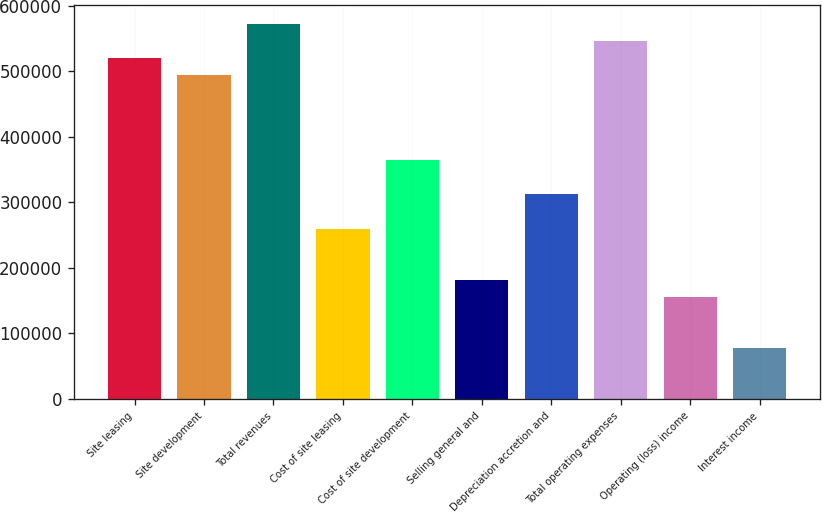<chart> <loc_0><loc_0><loc_500><loc_500><bar_chart><fcel>Site leasing<fcel>Site development<fcel>Total revenues<fcel>Cost of site leasing<fcel>Cost of site development<fcel>Selling general and<fcel>Depreciation accretion and<fcel>Total operating expenses<fcel>Operating (loss) income<fcel>Interest income<nl><fcel>519981<fcel>493982<fcel>571979<fcel>259991<fcel>363987<fcel>181994<fcel>311989<fcel>545980<fcel>155995<fcel>77998.2<nl></chart> 